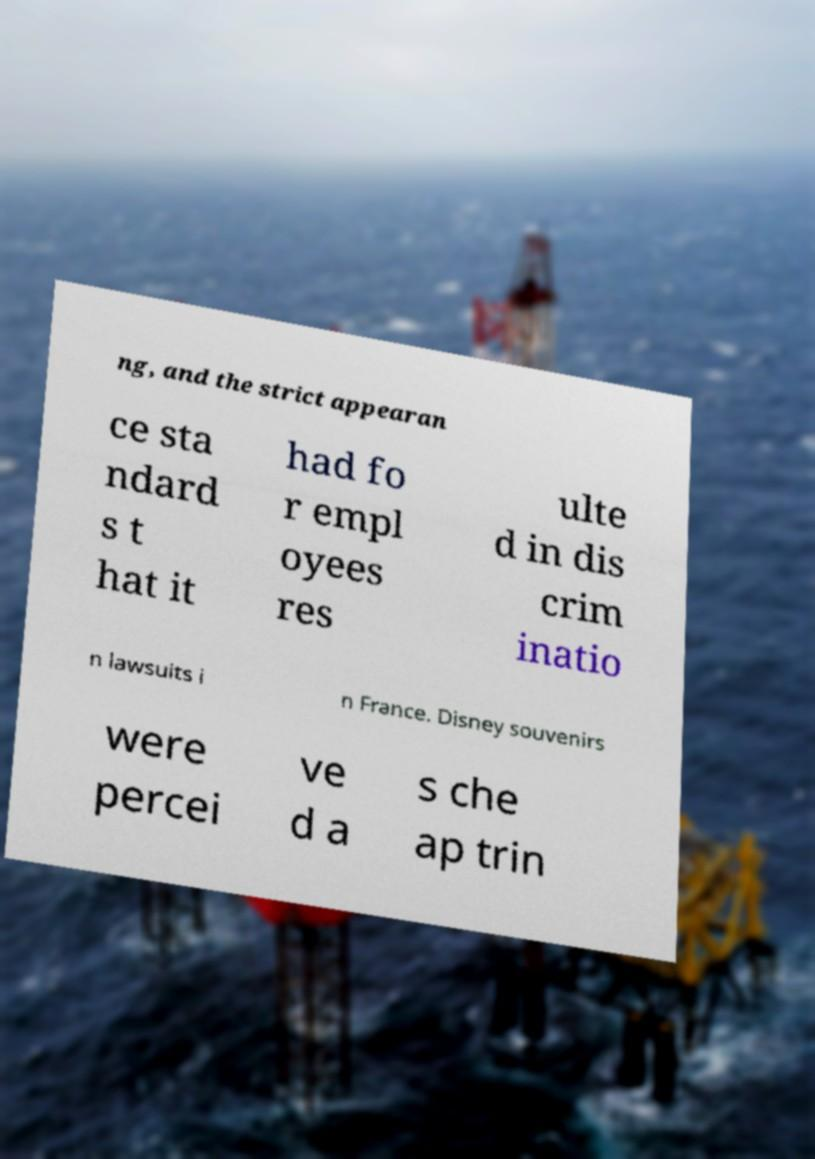Please identify and transcribe the text found in this image. ng, and the strict appearan ce sta ndard s t hat it had fo r empl oyees res ulte d in dis crim inatio n lawsuits i n France. Disney souvenirs were percei ve d a s che ap trin 